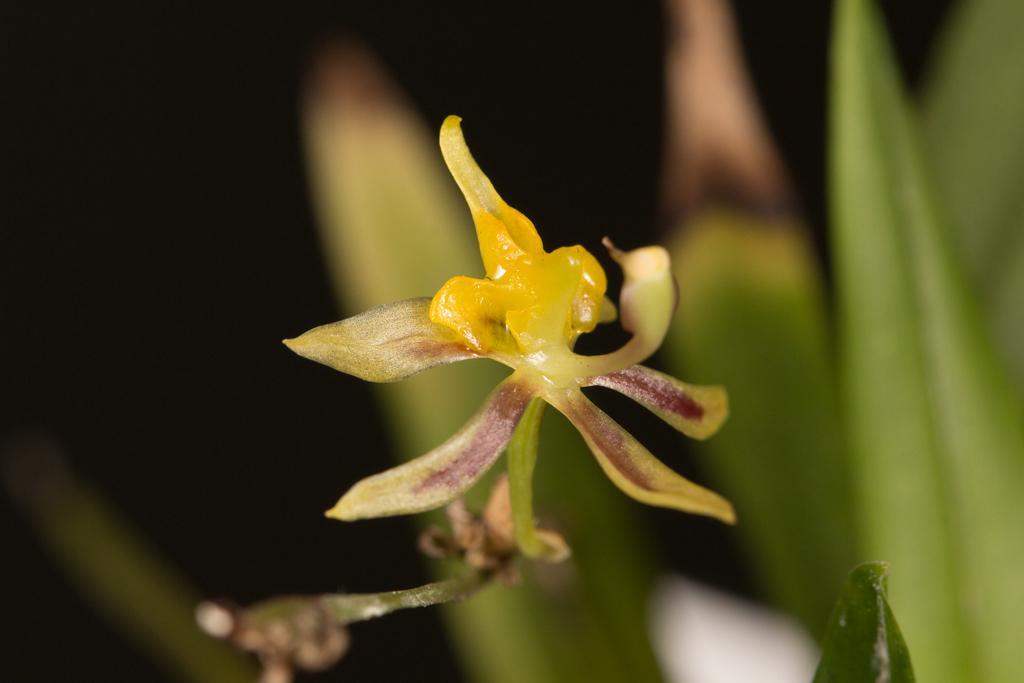Could you give a brief overview of what you see in this image? In this image we can see a flower and behind the flower we can see few leaves. 